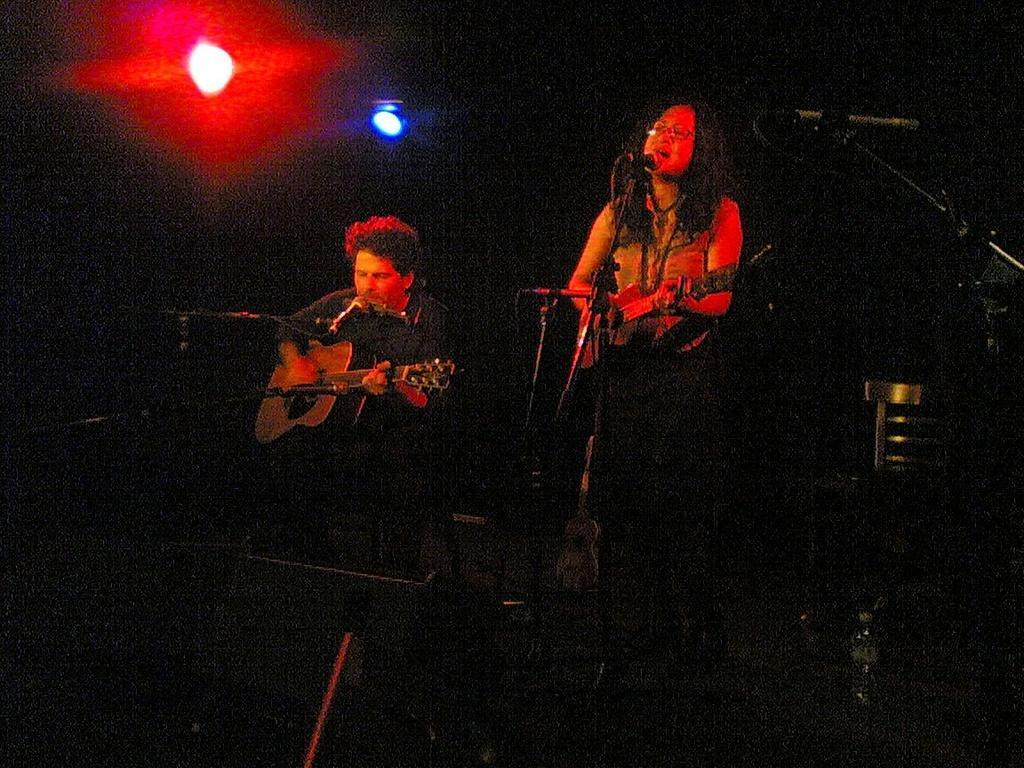Can you describe this image briefly? In this picture we can see a man and a woman playing guitar. These are the mikes and there are lights. 